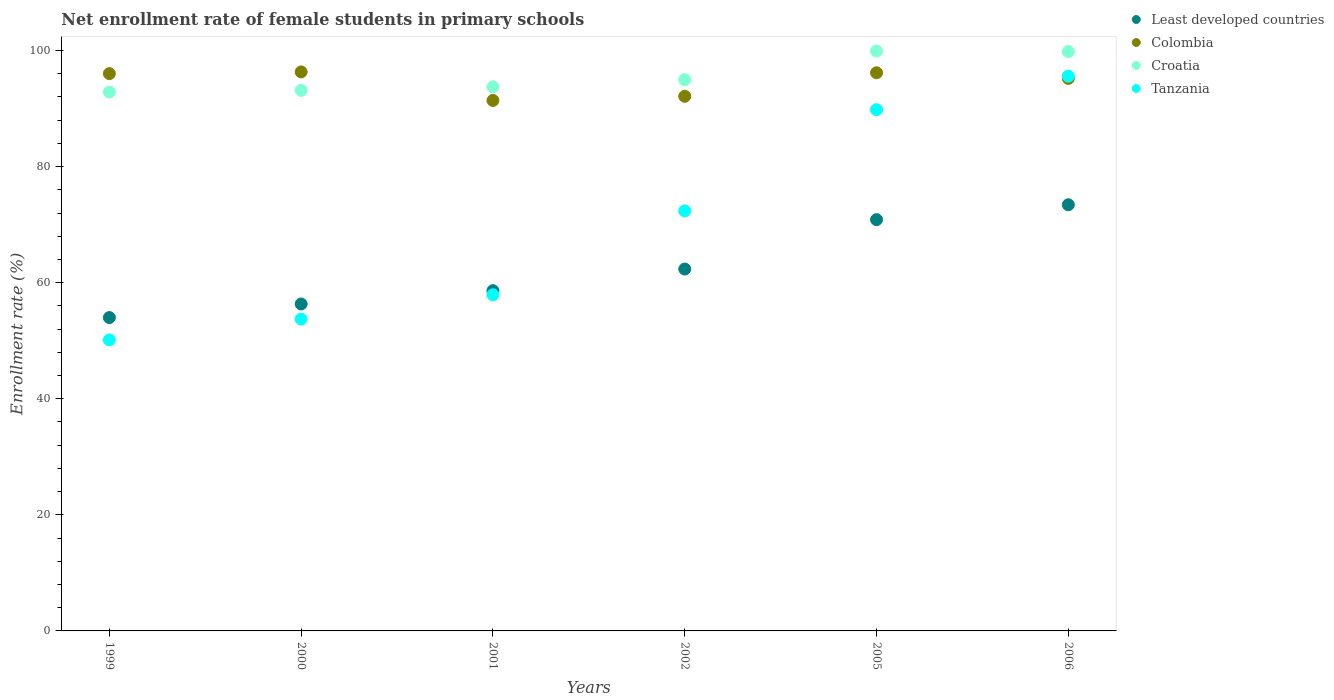How many different coloured dotlines are there?
Provide a succinct answer. 4. Is the number of dotlines equal to the number of legend labels?
Keep it short and to the point. Yes. What is the net enrollment rate of female students in primary schools in Colombia in 2001?
Your response must be concise. 91.4. Across all years, what is the maximum net enrollment rate of female students in primary schools in Least developed countries?
Provide a succinct answer. 73.43. Across all years, what is the minimum net enrollment rate of female students in primary schools in Least developed countries?
Make the answer very short. 53.99. In which year was the net enrollment rate of female students in primary schools in Least developed countries maximum?
Your response must be concise. 2006. In which year was the net enrollment rate of female students in primary schools in Colombia minimum?
Your answer should be very brief. 2001. What is the total net enrollment rate of female students in primary schools in Least developed countries in the graph?
Ensure brevity in your answer.  375.59. What is the difference between the net enrollment rate of female students in primary schools in Colombia in 2001 and that in 2002?
Provide a short and direct response. -0.72. What is the difference between the net enrollment rate of female students in primary schools in Tanzania in 2000 and the net enrollment rate of female students in primary schools in Colombia in 2001?
Keep it short and to the point. -37.67. What is the average net enrollment rate of female students in primary schools in Least developed countries per year?
Your answer should be compact. 62.6. In the year 2002, what is the difference between the net enrollment rate of female students in primary schools in Tanzania and net enrollment rate of female students in primary schools in Least developed countries?
Ensure brevity in your answer.  10.02. What is the ratio of the net enrollment rate of female students in primary schools in Colombia in 1999 to that in 2000?
Offer a very short reply. 1. Is the difference between the net enrollment rate of female students in primary schools in Tanzania in 2001 and 2002 greater than the difference between the net enrollment rate of female students in primary schools in Least developed countries in 2001 and 2002?
Your response must be concise. No. What is the difference between the highest and the second highest net enrollment rate of female students in primary schools in Colombia?
Offer a terse response. 0.15. What is the difference between the highest and the lowest net enrollment rate of female students in primary schools in Tanzania?
Your answer should be very brief. 45.45. Is the sum of the net enrollment rate of female students in primary schools in Colombia in 2000 and 2001 greater than the maximum net enrollment rate of female students in primary schools in Croatia across all years?
Ensure brevity in your answer.  Yes. Is it the case that in every year, the sum of the net enrollment rate of female students in primary schools in Colombia and net enrollment rate of female students in primary schools in Croatia  is greater than the net enrollment rate of female students in primary schools in Tanzania?
Give a very brief answer. Yes. Is the net enrollment rate of female students in primary schools in Least developed countries strictly greater than the net enrollment rate of female students in primary schools in Croatia over the years?
Your response must be concise. No. Are the values on the major ticks of Y-axis written in scientific E-notation?
Your answer should be compact. No. Does the graph contain any zero values?
Provide a succinct answer. No. How many legend labels are there?
Provide a succinct answer. 4. How are the legend labels stacked?
Provide a short and direct response. Vertical. What is the title of the graph?
Provide a short and direct response. Net enrollment rate of female students in primary schools. What is the label or title of the Y-axis?
Ensure brevity in your answer.  Enrollment rate (%). What is the Enrollment rate (%) in Least developed countries in 1999?
Offer a very short reply. 53.99. What is the Enrollment rate (%) of Colombia in 1999?
Give a very brief answer. 96.03. What is the Enrollment rate (%) of Croatia in 1999?
Give a very brief answer. 92.85. What is the Enrollment rate (%) of Tanzania in 1999?
Your answer should be very brief. 50.14. What is the Enrollment rate (%) in Least developed countries in 2000?
Your answer should be compact. 56.33. What is the Enrollment rate (%) in Colombia in 2000?
Your response must be concise. 96.32. What is the Enrollment rate (%) in Croatia in 2000?
Make the answer very short. 93.14. What is the Enrollment rate (%) in Tanzania in 2000?
Ensure brevity in your answer.  53.73. What is the Enrollment rate (%) of Least developed countries in 2001?
Give a very brief answer. 58.63. What is the Enrollment rate (%) in Colombia in 2001?
Your answer should be very brief. 91.4. What is the Enrollment rate (%) in Croatia in 2001?
Make the answer very short. 93.76. What is the Enrollment rate (%) of Tanzania in 2001?
Make the answer very short. 57.92. What is the Enrollment rate (%) in Least developed countries in 2002?
Ensure brevity in your answer.  62.35. What is the Enrollment rate (%) in Colombia in 2002?
Ensure brevity in your answer.  92.12. What is the Enrollment rate (%) in Croatia in 2002?
Your response must be concise. 94.98. What is the Enrollment rate (%) of Tanzania in 2002?
Your response must be concise. 72.37. What is the Enrollment rate (%) of Least developed countries in 2005?
Provide a succinct answer. 70.86. What is the Enrollment rate (%) of Colombia in 2005?
Offer a terse response. 96.17. What is the Enrollment rate (%) of Croatia in 2005?
Ensure brevity in your answer.  99.92. What is the Enrollment rate (%) of Tanzania in 2005?
Ensure brevity in your answer.  89.81. What is the Enrollment rate (%) in Least developed countries in 2006?
Provide a succinct answer. 73.43. What is the Enrollment rate (%) of Colombia in 2006?
Offer a very short reply. 95.2. What is the Enrollment rate (%) of Croatia in 2006?
Your response must be concise. 99.83. What is the Enrollment rate (%) of Tanzania in 2006?
Ensure brevity in your answer.  95.59. Across all years, what is the maximum Enrollment rate (%) in Least developed countries?
Give a very brief answer. 73.43. Across all years, what is the maximum Enrollment rate (%) in Colombia?
Provide a short and direct response. 96.32. Across all years, what is the maximum Enrollment rate (%) in Croatia?
Offer a very short reply. 99.92. Across all years, what is the maximum Enrollment rate (%) of Tanzania?
Provide a succinct answer. 95.59. Across all years, what is the minimum Enrollment rate (%) of Least developed countries?
Your response must be concise. 53.99. Across all years, what is the minimum Enrollment rate (%) in Colombia?
Ensure brevity in your answer.  91.4. Across all years, what is the minimum Enrollment rate (%) of Croatia?
Provide a short and direct response. 92.85. Across all years, what is the minimum Enrollment rate (%) in Tanzania?
Give a very brief answer. 50.14. What is the total Enrollment rate (%) of Least developed countries in the graph?
Your answer should be very brief. 375.59. What is the total Enrollment rate (%) in Colombia in the graph?
Ensure brevity in your answer.  567.24. What is the total Enrollment rate (%) in Croatia in the graph?
Your response must be concise. 574.48. What is the total Enrollment rate (%) in Tanzania in the graph?
Provide a short and direct response. 419.56. What is the difference between the Enrollment rate (%) of Least developed countries in 1999 and that in 2000?
Give a very brief answer. -2.34. What is the difference between the Enrollment rate (%) in Colombia in 1999 and that in 2000?
Your answer should be very brief. -0.3. What is the difference between the Enrollment rate (%) of Croatia in 1999 and that in 2000?
Make the answer very short. -0.29. What is the difference between the Enrollment rate (%) in Tanzania in 1999 and that in 2000?
Your response must be concise. -3.59. What is the difference between the Enrollment rate (%) of Least developed countries in 1999 and that in 2001?
Make the answer very short. -4.64. What is the difference between the Enrollment rate (%) of Colombia in 1999 and that in 2001?
Your answer should be very brief. 4.62. What is the difference between the Enrollment rate (%) in Croatia in 1999 and that in 2001?
Give a very brief answer. -0.91. What is the difference between the Enrollment rate (%) of Tanzania in 1999 and that in 2001?
Keep it short and to the point. -7.77. What is the difference between the Enrollment rate (%) in Least developed countries in 1999 and that in 2002?
Provide a short and direct response. -8.36. What is the difference between the Enrollment rate (%) in Colombia in 1999 and that in 2002?
Make the answer very short. 3.91. What is the difference between the Enrollment rate (%) of Croatia in 1999 and that in 2002?
Your answer should be very brief. -2.13. What is the difference between the Enrollment rate (%) in Tanzania in 1999 and that in 2002?
Provide a succinct answer. -22.23. What is the difference between the Enrollment rate (%) in Least developed countries in 1999 and that in 2005?
Give a very brief answer. -16.87. What is the difference between the Enrollment rate (%) of Colombia in 1999 and that in 2005?
Your answer should be compact. -0.15. What is the difference between the Enrollment rate (%) of Croatia in 1999 and that in 2005?
Provide a succinct answer. -7.07. What is the difference between the Enrollment rate (%) in Tanzania in 1999 and that in 2005?
Offer a very short reply. -39.67. What is the difference between the Enrollment rate (%) in Least developed countries in 1999 and that in 2006?
Your response must be concise. -19.44. What is the difference between the Enrollment rate (%) of Colombia in 1999 and that in 2006?
Give a very brief answer. 0.82. What is the difference between the Enrollment rate (%) in Croatia in 1999 and that in 2006?
Offer a terse response. -6.99. What is the difference between the Enrollment rate (%) in Tanzania in 1999 and that in 2006?
Ensure brevity in your answer.  -45.45. What is the difference between the Enrollment rate (%) of Least developed countries in 2000 and that in 2001?
Your response must be concise. -2.3. What is the difference between the Enrollment rate (%) of Colombia in 2000 and that in 2001?
Your answer should be very brief. 4.92. What is the difference between the Enrollment rate (%) of Croatia in 2000 and that in 2001?
Ensure brevity in your answer.  -0.62. What is the difference between the Enrollment rate (%) in Tanzania in 2000 and that in 2001?
Ensure brevity in your answer.  -4.19. What is the difference between the Enrollment rate (%) in Least developed countries in 2000 and that in 2002?
Keep it short and to the point. -6.02. What is the difference between the Enrollment rate (%) in Colombia in 2000 and that in 2002?
Keep it short and to the point. 4.2. What is the difference between the Enrollment rate (%) in Croatia in 2000 and that in 2002?
Ensure brevity in your answer.  -1.84. What is the difference between the Enrollment rate (%) of Tanzania in 2000 and that in 2002?
Provide a short and direct response. -18.65. What is the difference between the Enrollment rate (%) of Least developed countries in 2000 and that in 2005?
Provide a succinct answer. -14.53. What is the difference between the Enrollment rate (%) in Colombia in 2000 and that in 2005?
Give a very brief answer. 0.15. What is the difference between the Enrollment rate (%) in Croatia in 2000 and that in 2005?
Offer a terse response. -6.78. What is the difference between the Enrollment rate (%) in Tanzania in 2000 and that in 2005?
Ensure brevity in your answer.  -36.08. What is the difference between the Enrollment rate (%) of Least developed countries in 2000 and that in 2006?
Your answer should be very brief. -17.1. What is the difference between the Enrollment rate (%) in Colombia in 2000 and that in 2006?
Make the answer very short. 1.12. What is the difference between the Enrollment rate (%) in Croatia in 2000 and that in 2006?
Give a very brief answer. -6.69. What is the difference between the Enrollment rate (%) in Tanzania in 2000 and that in 2006?
Give a very brief answer. -41.86. What is the difference between the Enrollment rate (%) in Least developed countries in 2001 and that in 2002?
Ensure brevity in your answer.  -3.72. What is the difference between the Enrollment rate (%) of Colombia in 2001 and that in 2002?
Ensure brevity in your answer.  -0.72. What is the difference between the Enrollment rate (%) in Croatia in 2001 and that in 2002?
Give a very brief answer. -1.22. What is the difference between the Enrollment rate (%) of Tanzania in 2001 and that in 2002?
Keep it short and to the point. -14.46. What is the difference between the Enrollment rate (%) of Least developed countries in 2001 and that in 2005?
Your response must be concise. -12.23. What is the difference between the Enrollment rate (%) of Colombia in 2001 and that in 2005?
Provide a short and direct response. -4.77. What is the difference between the Enrollment rate (%) in Croatia in 2001 and that in 2005?
Make the answer very short. -6.16. What is the difference between the Enrollment rate (%) of Tanzania in 2001 and that in 2005?
Your response must be concise. -31.9. What is the difference between the Enrollment rate (%) in Least developed countries in 2001 and that in 2006?
Keep it short and to the point. -14.8. What is the difference between the Enrollment rate (%) in Colombia in 2001 and that in 2006?
Make the answer very short. -3.8. What is the difference between the Enrollment rate (%) of Croatia in 2001 and that in 2006?
Offer a terse response. -6.08. What is the difference between the Enrollment rate (%) of Tanzania in 2001 and that in 2006?
Give a very brief answer. -37.67. What is the difference between the Enrollment rate (%) of Least developed countries in 2002 and that in 2005?
Your response must be concise. -8.51. What is the difference between the Enrollment rate (%) in Colombia in 2002 and that in 2005?
Your answer should be very brief. -4.05. What is the difference between the Enrollment rate (%) in Croatia in 2002 and that in 2005?
Provide a short and direct response. -4.94. What is the difference between the Enrollment rate (%) of Tanzania in 2002 and that in 2005?
Keep it short and to the point. -17.44. What is the difference between the Enrollment rate (%) of Least developed countries in 2002 and that in 2006?
Offer a very short reply. -11.08. What is the difference between the Enrollment rate (%) in Colombia in 2002 and that in 2006?
Keep it short and to the point. -3.08. What is the difference between the Enrollment rate (%) in Croatia in 2002 and that in 2006?
Offer a very short reply. -4.86. What is the difference between the Enrollment rate (%) in Tanzania in 2002 and that in 2006?
Provide a short and direct response. -23.22. What is the difference between the Enrollment rate (%) of Least developed countries in 2005 and that in 2006?
Ensure brevity in your answer.  -2.57. What is the difference between the Enrollment rate (%) of Colombia in 2005 and that in 2006?
Provide a succinct answer. 0.97. What is the difference between the Enrollment rate (%) in Croatia in 2005 and that in 2006?
Offer a terse response. 0.09. What is the difference between the Enrollment rate (%) in Tanzania in 2005 and that in 2006?
Offer a very short reply. -5.78. What is the difference between the Enrollment rate (%) of Least developed countries in 1999 and the Enrollment rate (%) of Colombia in 2000?
Your answer should be very brief. -42.33. What is the difference between the Enrollment rate (%) of Least developed countries in 1999 and the Enrollment rate (%) of Croatia in 2000?
Your answer should be compact. -39.15. What is the difference between the Enrollment rate (%) of Least developed countries in 1999 and the Enrollment rate (%) of Tanzania in 2000?
Ensure brevity in your answer.  0.26. What is the difference between the Enrollment rate (%) in Colombia in 1999 and the Enrollment rate (%) in Croatia in 2000?
Make the answer very short. 2.88. What is the difference between the Enrollment rate (%) of Colombia in 1999 and the Enrollment rate (%) of Tanzania in 2000?
Provide a short and direct response. 42.3. What is the difference between the Enrollment rate (%) of Croatia in 1999 and the Enrollment rate (%) of Tanzania in 2000?
Offer a terse response. 39.12. What is the difference between the Enrollment rate (%) in Least developed countries in 1999 and the Enrollment rate (%) in Colombia in 2001?
Make the answer very short. -37.41. What is the difference between the Enrollment rate (%) of Least developed countries in 1999 and the Enrollment rate (%) of Croatia in 2001?
Keep it short and to the point. -39.77. What is the difference between the Enrollment rate (%) in Least developed countries in 1999 and the Enrollment rate (%) in Tanzania in 2001?
Offer a terse response. -3.92. What is the difference between the Enrollment rate (%) of Colombia in 1999 and the Enrollment rate (%) of Croatia in 2001?
Your response must be concise. 2.27. What is the difference between the Enrollment rate (%) of Colombia in 1999 and the Enrollment rate (%) of Tanzania in 2001?
Offer a terse response. 38.11. What is the difference between the Enrollment rate (%) of Croatia in 1999 and the Enrollment rate (%) of Tanzania in 2001?
Your answer should be very brief. 34.93. What is the difference between the Enrollment rate (%) in Least developed countries in 1999 and the Enrollment rate (%) in Colombia in 2002?
Give a very brief answer. -38.13. What is the difference between the Enrollment rate (%) of Least developed countries in 1999 and the Enrollment rate (%) of Croatia in 2002?
Make the answer very short. -40.99. What is the difference between the Enrollment rate (%) of Least developed countries in 1999 and the Enrollment rate (%) of Tanzania in 2002?
Provide a succinct answer. -18.38. What is the difference between the Enrollment rate (%) in Colombia in 1999 and the Enrollment rate (%) in Croatia in 2002?
Provide a short and direct response. 1.05. What is the difference between the Enrollment rate (%) in Colombia in 1999 and the Enrollment rate (%) in Tanzania in 2002?
Keep it short and to the point. 23.65. What is the difference between the Enrollment rate (%) in Croatia in 1999 and the Enrollment rate (%) in Tanzania in 2002?
Provide a short and direct response. 20.47. What is the difference between the Enrollment rate (%) in Least developed countries in 1999 and the Enrollment rate (%) in Colombia in 2005?
Make the answer very short. -42.18. What is the difference between the Enrollment rate (%) in Least developed countries in 1999 and the Enrollment rate (%) in Croatia in 2005?
Ensure brevity in your answer.  -45.93. What is the difference between the Enrollment rate (%) in Least developed countries in 1999 and the Enrollment rate (%) in Tanzania in 2005?
Ensure brevity in your answer.  -35.82. What is the difference between the Enrollment rate (%) in Colombia in 1999 and the Enrollment rate (%) in Croatia in 2005?
Offer a very short reply. -3.9. What is the difference between the Enrollment rate (%) in Colombia in 1999 and the Enrollment rate (%) in Tanzania in 2005?
Ensure brevity in your answer.  6.21. What is the difference between the Enrollment rate (%) in Croatia in 1999 and the Enrollment rate (%) in Tanzania in 2005?
Your answer should be very brief. 3.04. What is the difference between the Enrollment rate (%) in Least developed countries in 1999 and the Enrollment rate (%) in Colombia in 2006?
Your answer should be very brief. -41.21. What is the difference between the Enrollment rate (%) in Least developed countries in 1999 and the Enrollment rate (%) in Croatia in 2006?
Provide a short and direct response. -45.84. What is the difference between the Enrollment rate (%) of Least developed countries in 1999 and the Enrollment rate (%) of Tanzania in 2006?
Give a very brief answer. -41.6. What is the difference between the Enrollment rate (%) in Colombia in 1999 and the Enrollment rate (%) in Croatia in 2006?
Provide a succinct answer. -3.81. What is the difference between the Enrollment rate (%) of Colombia in 1999 and the Enrollment rate (%) of Tanzania in 2006?
Offer a terse response. 0.43. What is the difference between the Enrollment rate (%) of Croatia in 1999 and the Enrollment rate (%) of Tanzania in 2006?
Offer a very short reply. -2.74. What is the difference between the Enrollment rate (%) in Least developed countries in 2000 and the Enrollment rate (%) in Colombia in 2001?
Your response must be concise. -35.07. What is the difference between the Enrollment rate (%) of Least developed countries in 2000 and the Enrollment rate (%) of Croatia in 2001?
Ensure brevity in your answer.  -37.42. What is the difference between the Enrollment rate (%) of Least developed countries in 2000 and the Enrollment rate (%) of Tanzania in 2001?
Give a very brief answer. -1.58. What is the difference between the Enrollment rate (%) of Colombia in 2000 and the Enrollment rate (%) of Croatia in 2001?
Your answer should be very brief. 2.56. What is the difference between the Enrollment rate (%) of Colombia in 2000 and the Enrollment rate (%) of Tanzania in 2001?
Make the answer very short. 38.41. What is the difference between the Enrollment rate (%) of Croatia in 2000 and the Enrollment rate (%) of Tanzania in 2001?
Ensure brevity in your answer.  35.23. What is the difference between the Enrollment rate (%) in Least developed countries in 2000 and the Enrollment rate (%) in Colombia in 2002?
Give a very brief answer. -35.79. What is the difference between the Enrollment rate (%) of Least developed countries in 2000 and the Enrollment rate (%) of Croatia in 2002?
Your answer should be very brief. -38.65. What is the difference between the Enrollment rate (%) in Least developed countries in 2000 and the Enrollment rate (%) in Tanzania in 2002?
Offer a terse response. -16.04. What is the difference between the Enrollment rate (%) of Colombia in 2000 and the Enrollment rate (%) of Croatia in 2002?
Ensure brevity in your answer.  1.34. What is the difference between the Enrollment rate (%) of Colombia in 2000 and the Enrollment rate (%) of Tanzania in 2002?
Make the answer very short. 23.95. What is the difference between the Enrollment rate (%) of Croatia in 2000 and the Enrollment rate (%) of Tanzania in 2002?
Your answer should be compact. 20.77. What is the difference between the Enrollment rate (%) in Least developed countries in 2000 and the Enrollment rate (%) in Colombia in 2005?
Make the answer very short. -39.84. What is the difference between the Enrollment rate (%) of Least developed countries in 2000 and the Enrollment rate (%) of Croatia in 2005?
Ensure brevity in your answer.  -43.59. What is the difference between the Enrollment rate (%) of Least developed countries in 2000 and the Enrollment rate (%) of Tanzania in 2005?
Keep it short and to the point. -33.48. What is the difference between the Enrollment rate (%) of Colombia in 2000 and the Enrollment rate (%) of Croatia in 2005?
Give a very brief answer. -3.6. What is the difference between the Enrollment rate (%) in Colombia in 2000 and the Enrollment rate (%) in Tanzania in 2005?
Provide a short and direct response. 6.51. What is the difference between the Enrollment rate (%) in Croatia in 2000 and the Enrollment rate (%) in Tanzania in 2005?
Provide a succinct answer. 3.33. What is the difference between the Enrollment rate (%) of Least developed countries in 2000 and the Enrollment rate (%) of Colombia in 2006?
Provide a succinct answer. -38.87. What is the difference between the Enrollment rate (%) in Least developed countries in 2000 and the Enrollment rate (%) in Croatia in 2006?
Make the answer very short. -43.5. What is the difference between the Enrollment rate (%) of Least developed countries in 2000 and the Enrollment rate (%) of Tanzania in 2006?
Your answer should be very brief. -39.26. What is the difference between the Enrollment rate (%) in Colombia in 2000 and the Enrollment rate (%) in Croatia in 2006?
Your response must be concise. -3.51. What is the difference between the Enrollment rate (%) of Colombia in 2000 and the Enrollment rate (%) of Tanzania in 2006?
Provide a succinct answer. 0.73. What is the difference between the Enrollment rate (%) of Croatia in 2000 and the Enrollment rate (%) of Tanzania in 2006?
Offer a terse response. -2.45. What is the difference between the Enrollment rate (%) in Least developed countries in 2001 and the Enrollment rate (%) in Colombia in 2002?
Offer a very short reply. -33.49. What is the difference between the Enrollment rate (%) in Least developed countries in 2001 and the Enrollment rate (%) in Croatia in 2002?
Give a very brief answer. -36.35. What is the difference between the Enrollment rate (%) of Least developed countries in 2001 and the Enrollment rate (%) of Tanzania in 2002?
Ensure brevity in your answer.  -13.74. What is the difference between the Enrollment rate (%) in Colombia in 2001 and the Enrollment rate (%) in Croatia in 2002?
Make the answer very short. -3.58. What is the difference between the Enrollment rate (%) in Colombia in 2001 and the Enrollment rate (%) in Tanzania in 2002?
Make the answer very short. 19.03. What is the difference between the Enrollment rate (%) of Croatia in 2001 and the Enrollment rate (%) of Tanzania in 2002?
Offer a very short reply. 21.38. What is the difference between the Enrollment rate (%) in Least developed countries in 2001 and the Enrollment rate (%) in Colombia in 2005?
Your answer should be very brief. -37.54. What is the difference between the Enrollment rate (%) in Least developed countries in 2001 and the Enrollment rate (%) in Croatia in 2005?
Offer a terse response. -41.29. What is the difference between the Enrollment rate (%) in Least developed countries in 2001 and the Enrollment rate (%) in Tanzania in 2005?
Ensure brevity in your answer.  -31.18. What is the difference between the Enrollment rate (%) in Colombia in 2001 and the Enrollment rate (%) in Croatia in 2005?
Keep it short and to the point. -8.52. What is the difference between the Enrollment rate (%) in Colombia in 2001 and the Enrollment rate (%) in Tanzania in 2005?
Give a very brief answer. 1.59. What is the difference between the Enrollment rate (%) in Croatia in 2001 and the Enrollment rate (%) in Tanzania in 2005?
Your response must be concise. 3.94. What is the difference between the Enrollment rate (%) in Least developed countries in 2001 and the Enrollment rate (%) in Colombia in 2006?
Offer a terse response. -36.57. What is the difference between the Enrollment rate (%) of Least developed countries in 2001 and the Enrollment rate (%) of Croatia in 2006?
Your answer should be compact. -41.2. What is the difference between the Enrollment rate (%) of Least developed countries in 2001 and the Enrollment rate (%) of Tanzania in 2006?
Provide a short and direct response. -36.96. What is the difference between the Enrollment rate (%) of Colombia in 2001 and the Enrollment rate (%) of Croatia in 2006?
Give a very brief answer. -8.43. What is the difference between the Enrollment rate (%) in Colombia in 2001 and the Enrollment rate (%) in Tanzania in 2006?
Provide a succinct answer. -4.19. What is the difference between the Enrollment rate (%) of Croatia in 2001 and the Enrollment rate (%) of Tanzania in 2006?
Your answer should be very brief. -1.83. What is the difference between the Enrollment rate (%) of Least developed countries in 2002 and the Enrollment rate (%) of Colombia in 2005?
Ensure brevity in your answer.  -33.82. What is the difference between the Enrollment rate (%) of Least developed countries in 2002 and the Enrollment rate (%) of Croatia in 2005?
Your response must be concise. -37.57. What is the difference between the Enrollment rate (%) in Least developed countries in 2002 and the Enrollment rate (%) in Tanzania in 2005?
Your answer should be very brief. -27.46. What is the difference between the Enrollment rate (%) in Colombia in 2002 and the Enrollment rate (%) in Croatia in 2005?
Provide a succinct answer. -7.8. What is the difference between the Enrollment rate (%) in Colombia in 2002 and the Enrollment rate (%) in Tanzania in 2005?
Your answer should be very brief. 2.31. What is the difference between the Enrollment rate (%) of Croatia in 2002 and the Enrollment rate (%) of Tanzania in 2005?
Ensure brevity in your answer.  5.17. What is the difference between the Enrollment rate (%) in Least developed countries in 2002 and the Enrollment rate (%) in Colombia in 2006?
Provide a short and direct response. -32.85. What is the difference between the Enrollment rate (%) in Least developed countries in 2002 and the Enrollment rate (%) in Croatia in 2006?
Offer a very short reply. -37.48. What is the difference between the Enrollment rate (%) in Least developed countries in 2002 and the Enrollment rate (%) in Tanzania in 2006?
Your response must be concise. -33.24. What is the difference between the Enrollment rate (%) of Colombia in 2002 and the Enrollment rate (%) of Croatia in 2006?
Give a very brief answer. -7.72. What is the difference between the Enrollment rate (%) of Colombia in 2002 and the Enrollment rate (%) of Tanzania in 2006?
Keep it short and to the point. -3.47. What is the difference between the Enrollment rate (%) of Croatia in 2002 and the Enrollment rate (%) of Tanzania in 2006?
Ensure brevity in your answer.  -0.61. What is the difference between the Enrollment rate (%) of Least developed countries in 2005 and the Enrollment rate (%) of Colombia in 2006?
Give a very brief answer. -24.34. What is the difference between the Enrollment rate (%) in Least developed countries in 2005 and the Enrollment rate (%) in Croatia in 2006?
Provide a succinct answer. -28.97. What is the difference between the Enrollment rate (%) in Least developed countries in 2005 and the Enrollment rate (%) in Tanzania in 2006?
Your answer should be very brief. -24.73. What is the difference between the Enrollment rate (%) in Colombia in 2005 and the Enrollment rate (%) in Croatia in 2006?
Provide a short and direct response. -3.66. What is the difference between the Enrollment rate (%) in Colombia in 2005 and the Enrollment rate (%) in Tanzania in 2006?
Offer a terse response. 0.58. What is the difference between the Enrollment rate (%) of Croatia in 2005 and the Enrollment rate (%) of Tanzania in 2006?
Offer a very short reply. 4.33. What is the average Enrollment rate (%) of Least developed countries per year?
Make the answer very short. 62.6. What is the average Enrollment rate (%) in Colombia per year?
Make the answer very short. 94.54. What is the average Enrollment rate (%) of Croatia per year?
Provide a short and direct response. 95.75. What is the average Enrollment rate (%) in Tanzania per year?
Provide a succinct answer. 69.93. In the year 1999, what is the difference between the Enrollment rate (%) in Least developed countries and Enrollment rate (%) in Colombia?
Ensure brevity in your answer.  -42.03. In the year 1999, what is the difference between the Enrollment rate (%) of Least developed countries and Enrollment rate (%) of Croatia?
Provide a short and direct response. -38.86. In the year 1999, what is the difference between the Enrollment rate (%) of Least developed countries and Enrollment rate (%) of Tanzania?
Offer a very short reply. 3.85. In the year 1999, what is the difference between the Enrollment rate (%) of Colombia and Enrollment rate (%) of Croatia?
Your answer should be very brief. 3.18. In the year 1999, what is the difference between the Enrollment rate (%) of Colombia and Enrollment rate (%) of Tanzania?
Ensure brevity in your answer.  45.88. In the year 1999, what is the difference between the Enrollment rate (%) in Croatia and Enrollment rate (%) in Tanzania?
Make the answer very short. 42.71. In the year 2000, what is the difference between the Enrollment rate (%) of Least developed countries and Enrollment rate (%) of Colombia?
Ensure brevity in your answer.  -39.99. In the year 2000, what is the difference between the Enrollment rate (%) of Least developed countries and Enrollment rate (%) of Croatia?
Your answer should be compact. -36.81. In the year 2000, what is the difference between the Enrollment rate (%) in Least developed countries and Enrollment rate (%) in Tanzania?
Your answer should be compact. 2.6. In the year 2000, what is the difference between the Enrollment rate (%) in Colombia and Enrollment rate (%) in Croatia?
Make the answer very short. 3.18. In the year 2000, what is the difference between the Enrollment rate (%) of Colombia and Enrollment rate (%) of Tanzania?
Offer a very short reply. 42.59. In the year 2000, what is the difference between the Enrollment rate (%) of Croatia and Enrollment rate (%) of Tanzania?
Keep it short and to the point. 39.41. In the year 2001, what is the difference between the Enrollment rate (%) in Least developed countries and Enrollment rate (%) in Colombia?
Offer a terse response. -32.77. In the year 2001, what is the difference between the Enrollment rate (%) in Least developed countries and Enrollment rate (%) in Croatia?
Provide a short and direct response. -35.13. In the year 2001, what is the difference between the Enrollment rate (%) of Least developed countries and Enrollment rate (%) of Tanzania?
Your answer should be very brief. 0.71. In the year 2001, what is the difference between the Enrollment rate (%) of Colombia and Enrollment rate (%) of Croatia?
Offer a terse response. -2.35. In the year 2001, what is the difference between the Enrollment rate (%) of Colombia and Enrollment rate (%) of Tanzania?
Give a very brief answer. 33.49. In the year 2001, what is the difference between the Enrollment rate (%) of Croatia and Enrollment rate (%) of Tanzania?
Make the answer very short. 35.84. In the year 2002, what is the difference between the Enrollment rate (%) of Least developed countries and Enrollment rate (%) of Colombia?
Make the answer very short. -29.77. In the year 2002, what is the difference between the Enrollment rate (%) in Least developed countries and Enrollment rate (%) in Croatia?
Provide a succinct answer. -32.63. In the year 2002, what is the difference between the Enrollment rate (%) of Least developed countries and Enrollment rate (%) of Tanzania?
Ensure brevity in your answer.  -10.02. In the year 2002, what is the difference between the Enrollment rate (%) of Colombia and Enrollment rate (%) of Croatia?
Provide a succinct answer. -2.86. In the year 2002, what is the difference between the Enrollment rate (%) of Colombia and Enrollment rate (%) of Tanzania?
Offer a very short reply. 19.74. In the year 2002, what is the difference between the Enrollment rate (%) in Croatia and Enrollment rate (%) in Tanzania?
Offer a terse response. 22.6. In the year 2005, what is the difference between the Enrollment rate (%) in Least developed countries and Enrollment rate (%) in Colombia?
Your answer should be compact. -25.31. In the year 2005, what is the difference between the Enrollment rate (%) of Least developed countries and Enrollment rate (%) of Croatia?
Your answer should be compact. -29.06. In the year 2005, what is the difference between the Enrollment rate (%) of Least developed countries and Enrollment rate (%) of Tanzania?
Your response must be concise. -18.95. In the year 2005, what is the difference between the Enrollment rate (%) in Colombia and Enrollment rate (%) in Croatia?
Keep it short and to the point. -3.75. In the year 2005, what is the difference between the Enrollment rate (%) of Colombia and Enrollment rate (%) of Tanzania?
Ensure brevity in your answer.  6.36. In the year 2005, what is the difference between the Enrollment rate (%) in Croatia and Enrollment rate (%) in Tanzania?
Your answer should be very brief. 10.11. In the year 2006, what is the difference between the Enrollment rate (%) in Least developed countries and Enrollment rate (%) in Colombia?
Your answer should be compact. -21.77. In the year 2006, what is the difference between the Enrollment rate (%) of Least developed countries and Enrollment rate (%) of Croatia?
Provide a short and direct response. -26.4. In the year 2006, what is the difference between the Enrollment rate (%) in Least developed countries and Enrollment rate (%) in Tanzania?
Offer a very short reply. -22.16. In the year 2006, what is the difference between the Enrollment rate (%) of Colombia and Enrollment rate (%) of Croatia?
Ensure brevity in your answer.  -4.63. In the year 2006, what is the difference between the Enrollment rate (%) in Colombia and Enrollment rate (%) in Tanzania?
Keep it short and to the point. -0.39. In the year 2006, what is the difference between the Enrollment rate (%) of Croatia and Enrollment rate (%) of Tanzania?
Make the answer very short. 4.24. What is the ratio of the Enrollment rate (%) of Least developed countries in 1999 to that in 2000?
Your answer should be very brief. 0.96. What is the ratio of the Enrollment rate (%) of Tanzania in 1999 to that in 2000?
Provide a short and direct response. 0.93. What is the ratio of the Enrollment rate (%) in Least developed countries in 1999 to that in 2001?
Your response must be concise. 0.92. What is the ratio of the Enrollment rate (%) in Colombia in 1999 to that in 2001?
Ensure brevity in your answer.  1.05. What is the ratio of the Enrollment rate (%) of Croatia in 1999 to that in 2001?
Provide a succinct answer. 0.99. What is the ratio of the Enrollment rate (%) of Tanzania in 1999 to that in 2001?
Offer a terse response. 0.87. What is the ratio of the Enrollment rate (%) in Least developed countries in 1999 to that in 2002?
Your response must be concise. 0.87. What is the ratio of the Enrollment rate (%) in Colombia in 1999 to that in 2002?
Keep it short and to the point. 1.04. What is the ratio of the Enrollment rate (%) in Croatia in 1999 to that in 2002?
Ensure brevity in your answer.  0.98. What is the ratio of the Enrollment rate (%) of Tanzania in 1999 to that in 2002?
Your response must be concise. 0.69. What is the ratio of the Enrollment rate (%) of Least developed countries in 1999 to that in 2005?
Keep it short and to the point. 0.76. What is the ratio of the Enrollment rate (%) in Colombia in 1999 to that in 2005?
Your response must be concise. 1. What is the ratio of the Enrollment rate (%) of Croatia in 1999 to that in 2005?
Make the answer very short. 0.93. What is the ratio of the Enrollment rate (%) of Tanzania in 1999 to that in 2005?
Provide a succinct answer. 0.56. What is the ratio of the Enrollment rate (%) of Least developed countries in 1999 to that in 2006?
Ensure brevity in your answer.  0.74. What is the ratio of the Enrollment rate (%) in Colombia in 1999 to that in 2006?
Make the answer very short. 1.01. What is the ratio of the Enrollment rate (%) of Tanzania in 1999 to that in 2006?
Keep it short and to the point. 0.52. What is the ratio of the Enrollment rate (%) in Least developed countries in 2000 to that in 2001?
Provide a succinct answer. 0.96. What is the ratio of the Enrollment rate (%) of Colombia in 2000 to that in 2001?
Make the answer very short. 1.05. What is the ratio of the Enrollment rate (%) of Croatia in 2000 to that in 2001?
Make the answer very short. 0.99. What is the ratio of the Enrollment rate (%) in Tanzania in 2000 to that in 2001?
Provide a short and direct response. 0.93. What is the ratio of the Enrollment rate (%) of Least developed countries in 2000 to that in 2002?
Your answer should be very brief. 0.9. What is the ratio of the Enrollment rate (%) in Colombia in 2000 to that in 2002?
Keep it short and to the point. 1.05. What is the ratio of the Enrollment rate (%) in Croatia in 2000 to that in 2002?
Your answer should be compact. 0.98. What is the ratio of the Enrollment rate (%) of Tanzania in 2000 to that in 2002?
Ensure brevity in your answer.  0.74. What is the ratio of the Enrollment rate (%) in Least developed countries in 2000 to that in 2005?
Your response must be concise. 0.79. What is the ratio of the Enrollment rate (%) in Colombia in 2000 to that in 2005?
Provide a short and direct response. 1. What is the ratio of the Enrollment rate (%) of Croatia in 2000 to that in 2005?
Your answer should be compact. 0.93. What is the ratio of the Enrollment rate (%) of Tanzania in 2000 to that in 2005?
Make the answer very short. 0.6. What is the ratio of the Enrollment rate (%) of Least developed countries in 2000 to that in 2006?
Make the answer very short. 0.77. What is the ratio of the Enrollment rate (%) in Colombia in 2000 to that in 2006?
Ensure brevity in your answer.  1.01. What is the ratio of the Enrollment rate (%) of Croatia in 2000 to that in 2006?
Offer a very short reply. 0.93. What is the ratio of the Enrollment rate (%) in Tanzania in 2000 to that in 2006?
Provide a short and direct response. 0.56. What is the ratio of the Enrollment rate (%) of Least developed countries in 2001 to that in 2002?
Your response must be concise. 0.94. What is the ratio of the Enrollment rate (%) of Colombia in 2001 to that in 2002?
Offer a terse response. 0.99. What is the ratio of the Enrollment rate (%) in Croatia in 2001 to that in 2002?
Make the answer very short. 0.99. What is the ratio of the Enrollment rate (%) in Tanzania in 2001 to that in 2002?
Your response must be concise. 0.8. What is the ratio of the Enrollment rate (%) in Least developed countries in 2001 to that in 2005?
Your answer should be compact. 0.83. What is the ratio of the Enrollment rate (%) of Colombia in 2001 to that in 2005?
Ensure brevity in your answer.  0.95. What is the ratio of the Enrollment rate (%) in Croatia in 2001 to that in 2005?
Give a very brief answer. 0.94. What is the ratio of the Enrollment rate (%) in Tanzania in 2001 to that in 2005?
Your answer should be very brief. 0.64. What is the ratio of the Enrollment rate (%) in Least developed countries in 2001 to that in 2006?
Offer a very short reply. 0.8. What is the ratio of the Enrollment rate (%) of Colombia in 2001 to that in 2006?
Offer a very short reply. 0.96. What is the ratio of the Enrollment rate (%) in Croatia in 2001 to that in 2006?
Keep it short and to the point. 0.94. What is the ratio of the Enrollment rate (%) of Tanzania in 2001 to that in 2006?
Your response must be concise. 0.61. What is the ratio of the Enrollment rate (%) of Least developed countries in 2002 to that in 2005?
Offer a terse response. 0.88. What is the ratio of the Enrollment rate (%) of Colombia in 2002 to that in 2005?
Ensure brevity in your answer.  0.96. What is the ratio of the Enrollment rate (%) in Croatia in 2002 to that in 2005?
Your response must be concise. 0.95. What is the ratio of the Enrollment rate (%) of Tanzania in 2002 to that in 2005?
Make the answer very short. 0.81. What is the ratio of the Enrollment rate (%) in Least developed countries in 2002 to that in 2006?
Offer a very short reply. 0.85. What is the ratio of the Enrollment rate (%) of Colombia in 2002 to that in 2006?
Offer a terse response. 0.97. What is the ratio of the Enrollment rate (%) in Croatia in 2002 to that in 2006?
Your response must be concise. 0.95. What is the ratio of the Enrollment rate (%) in Tanzania in 2002 to that in 2006?
Keep it short and to the point. 0.76. What is the ratio of the Enrollment rate (%) in Colombia in 2005 to that in 2006?
Ensure brevity in your answer.  1.01. What is the ratio of the Enrollment rate (%) of Croatia in 2005 to that in 2006?
Provide a succinct answer. 1. What is the ratio of the Enrollment rate (%) in Tanzania in 2005 to that in 2006?
Give a very brief answer. 0.94. What is the difference between the highest and the second highest Enrollment rate (%) in Least developed countries?
Give a very brief answer. 2.57. What is the difference between the highest and the second highest Enrollment rate (%) in Colombia?
Your answer should be very brief. 0.15. What is the difference between the highest and the second highest Enrollment rate (%) in Croatia?
Your answer should be very brief. 0.09. What is the difference between the highest and the second highest Enrollment rate (%) in Tanzania?
Give a very brief answer. 5.78. What is the difference between the highest and the lowest Enrollment rate (%) in Least developed countries?
Offer a very short reply. 19.44. What is the difference between the highest and the lowest Enrollment rate (%) in Colombia?
Your answer should be compact. 4.92. What is the difference between the highest and the lowest Enrollment rate (%) in Croatia?
Provide a short and direct response. 7.07. What is the difference between the highest and the lowest Enrollment rate (%) in Tanzania?
Ensure brevity in your answer.  45.45. 